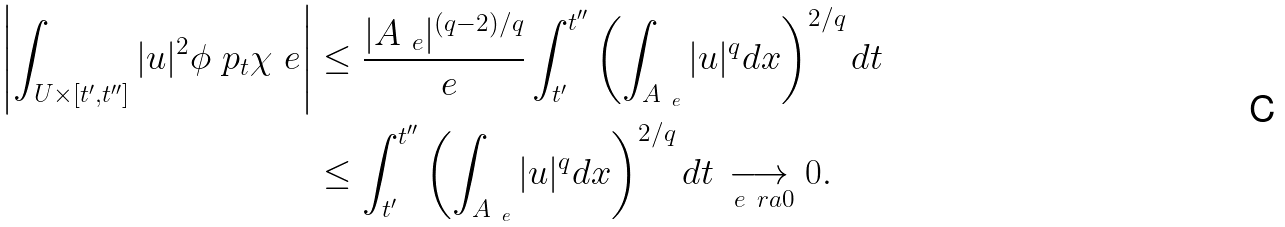Convert formula to latex. <formula><loc_0><loc_0><loc_500><loc_500>\left | \int _ { U \times [ t ^ { \prime } , t ^ { \prime \prime } ] } | u | ^ { 2 } \phi \ p _ { t } \chi _ { \ } e \right | & \leq \frac { | A _ { \ e } | ^ { ( q - 2 ) / q } } { \ e } \int _ { t ^ { \prime } } ^ { t ^ { \prime \prime } } \left ( \int _ { A _ { \ e } } | u | ^ { q } d x \right ) ^ { 2 / q } d t \\ & \leq \int _ { t ^ { \prime } } ^ { t ^ { \prime \prime } } \left ( \int _ { A _ { \ e } } | u | ^ { q } d x \right ) ^ { 2 / q } d t \underset { \ e \ r a 0 } { \longrightarrow } 0 .</formula> 